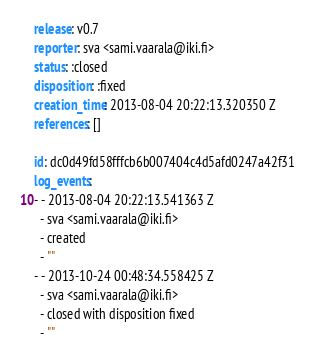Convert code to text. <code><loc_0><loc_0><loc_500><loc_500><_YAML_>release: v0.7
reporter: sva <sami.vaarala@iki.fi>
status: :closed
disposition: :fixed
creation_time: 2013-08-04 20:22:13.320350 Z
references: []

id: dc0d49fd58fffcb6b007404c4d5afd0247a42f31
log_events: 
- - 2013-08-04 20:22:13.541363 Z
  - sva <sami.vaarala@iki.fi>
  - created
  - ""
- - 2013-10-24 00:48:34.558425 Z
  - sva <sami.vaarala@iki.fi>
  - closed with disposition fixed
  - ""
</code> 